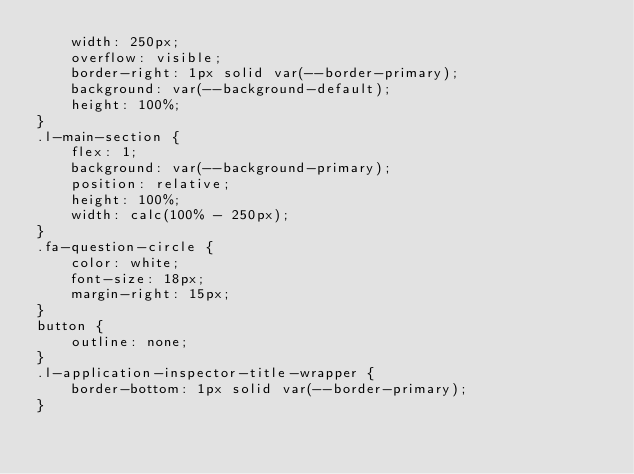Convert code to text. <code><loc_0><loc_0><loc_500><loc_500><_CSS_>    width: 250px;
    overflow: visible;
    border-right: 1px solid var(--border-primary);
    background: var(--background-default);
    height: 100%;
}
.l-main-section {
    flex: 1;
    background: var(--background-primary);
    position: relative;
    height: 100%;
    width: calc(100% - 250px);
}
.fa-question-circle {
    color: white;
    font-size: 18px;
    margin-right: 15px;
}
button {
    outline: none;
}
.l-application-inspector-title-wrapper {
    border-bottom: 1px solid var(--border-primary);
}
</code> 